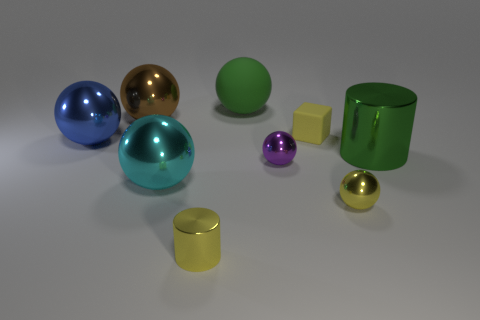What is the color of the other rubber object that is the same shape as the blue object?
Your answer should be compact. Green. What number of brown objects are small cylinders or big rubber things?
Ensure brevity in your answer.  0. The small yellow thing behind the ball in front of the cyan shiny ball is made of what material?
Provide a succinct answer. Rubber. Is the shape of the brown shiny thing the same as the green shiny object?
Give a very brief answer. No. There is a metal cylinder that is the same size as the brown object; what is its color?
Keep it short and to the point. Green. Is there a cylinder of the same color as the rubber ball?
Provide a short and direct response. Yes. Is there a yellow matte sphere?
Provide a short and direct response. No. Do the large ball that is on the right side of the small yellow metallic cylinder and the blue object have the same material?
Your answer should be compact. No. There is a sphere that is the same color as the tiny rubber thing; what is its size?
Provide a short and direct response. Small. How many brown metal spheres have the same size as the cyan metallic object?
Keep it short and to the point. 1. 